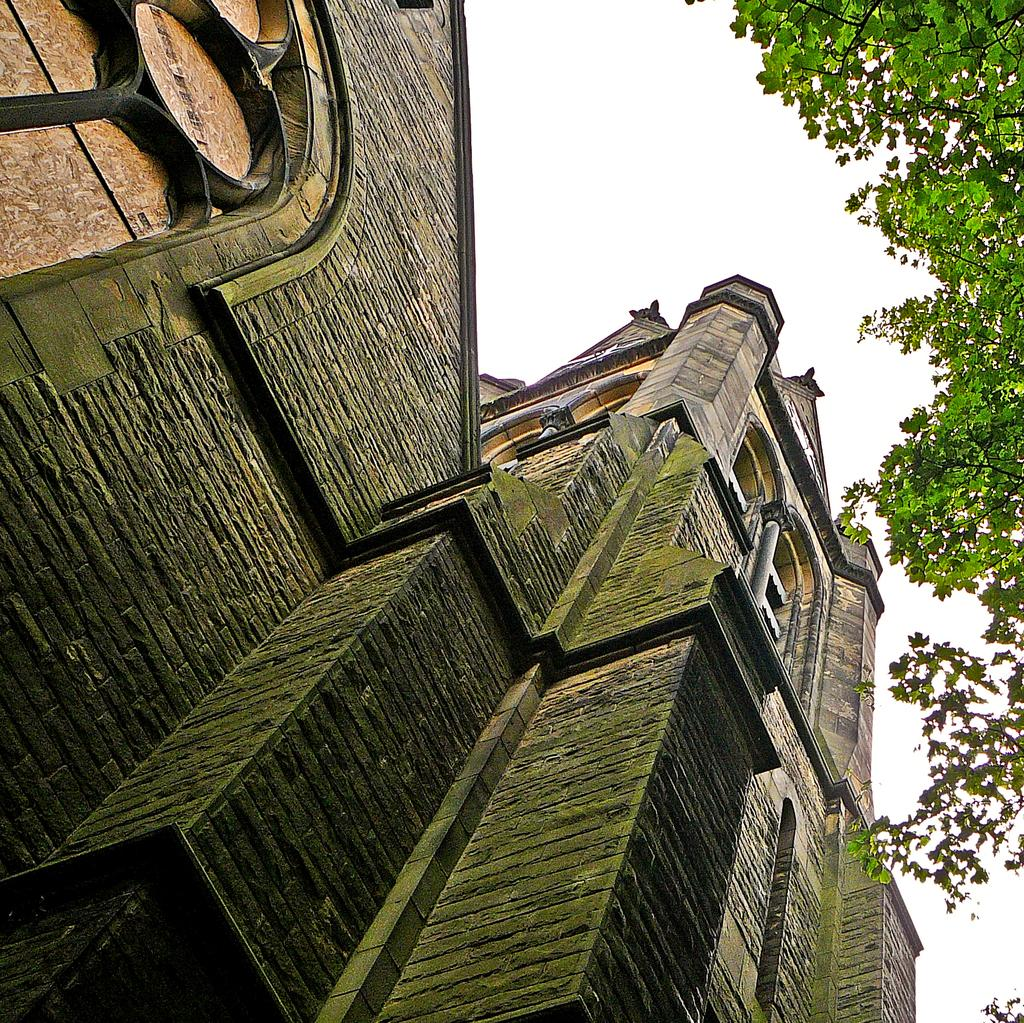What type of building is shown in the image? There is a bungalow in the image. What structural elements can be seen in the image? Walls are visible in the image. What type of vegetation is on the right side of the image? There is a tree on the right side of the image. What is visible in the background of the image? The sky is visible in the background of the image. What type of earth is being cultivated by the governor in the image? There is no governor or cultivation present in the image; it features a bungalow, walls, a tree, and the sky. 